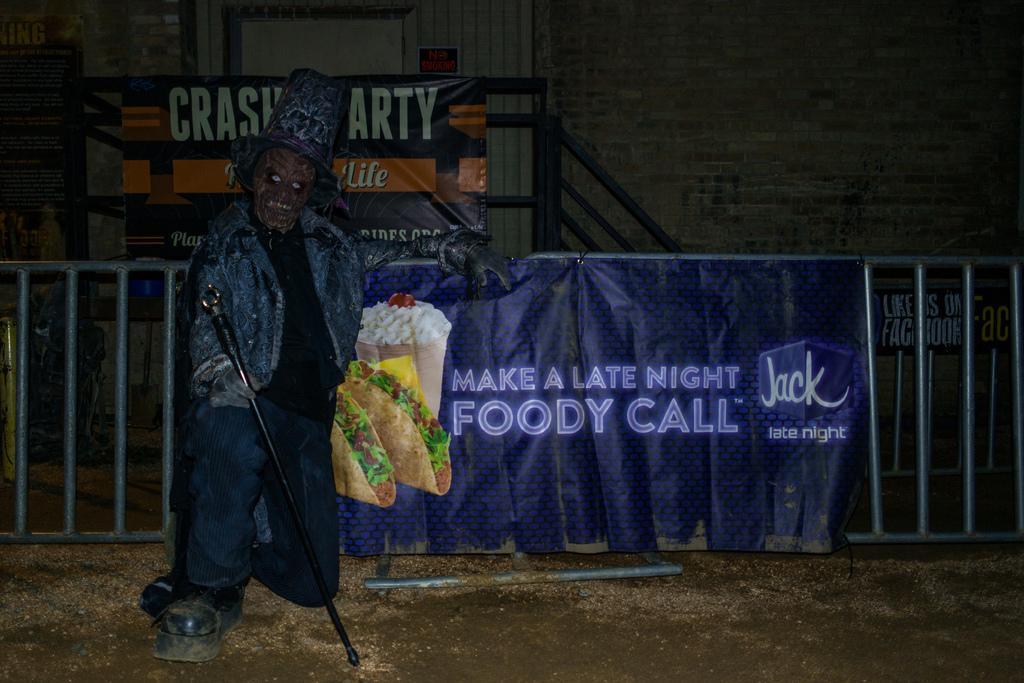Please provide a concise description of this image. In this image I can see a person wearing a costume and holding a black colored stick in his hand and I can see a banner which is blue in color and the metal railing. In the background I can see the building, the metal railing, a banner to the railing and few posters attached to the wall. 